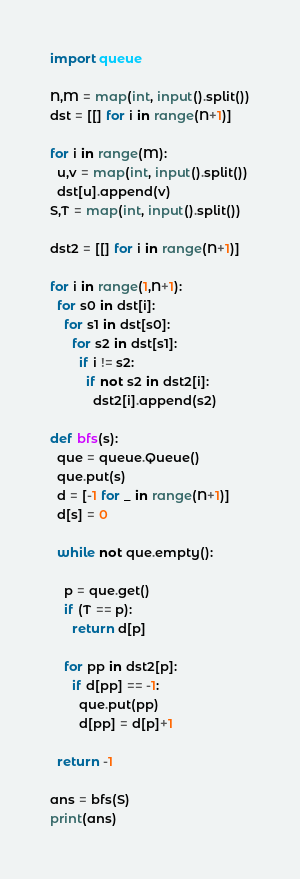Convert code to text. <code><loc_0><loc_0><loc_500><loc_500><_Python_>import queue

N,M = map(int, input().split())
dst = [[] for i in range(N+1)]

for i in range(M):
  u,v = map(int, input().split())
  dst[u].append(v)
S,T = map(int, input().split())

dst2 = [[] for i in range(N+1)]

for i in range(1,N+1):
  for s0 in dst[i]:
    for s1 in dst[s0]:
      for s2 in dst[s1]:
        if i != s2:
          if not s2 in dst2[i]:
            dst2[i].append(s2)
  
def bfs(s):
  que = queue.Queue()
  que.put(s)
  d = [-1 for _ in range(N+1)]
  d[s] = 0

  while not que.empty():

    p = que.get()
    if (T == p):
      return d[p]

    for pp in dst2[p]:
      if d[pp] == -1:
        que.put(pp)
        d[pp] = d[p]+1

  return -1

ans = bfs(S)
print(ans)
</code> 